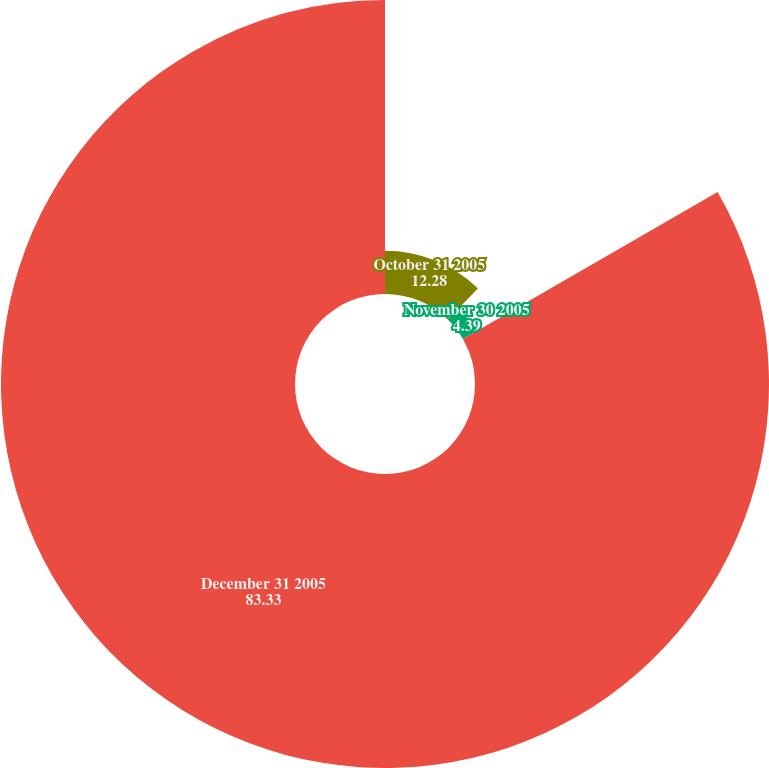Convert chart. <chart><loc_0><loc_0><loc_500><loc_500><pie_chart><fcel>October 31 2005<fcel>November 30 2005<fcel>December 31 2005<nl><fcel>12.28%<fcel>4.39%<fcel>83.33%<nl></chart> 